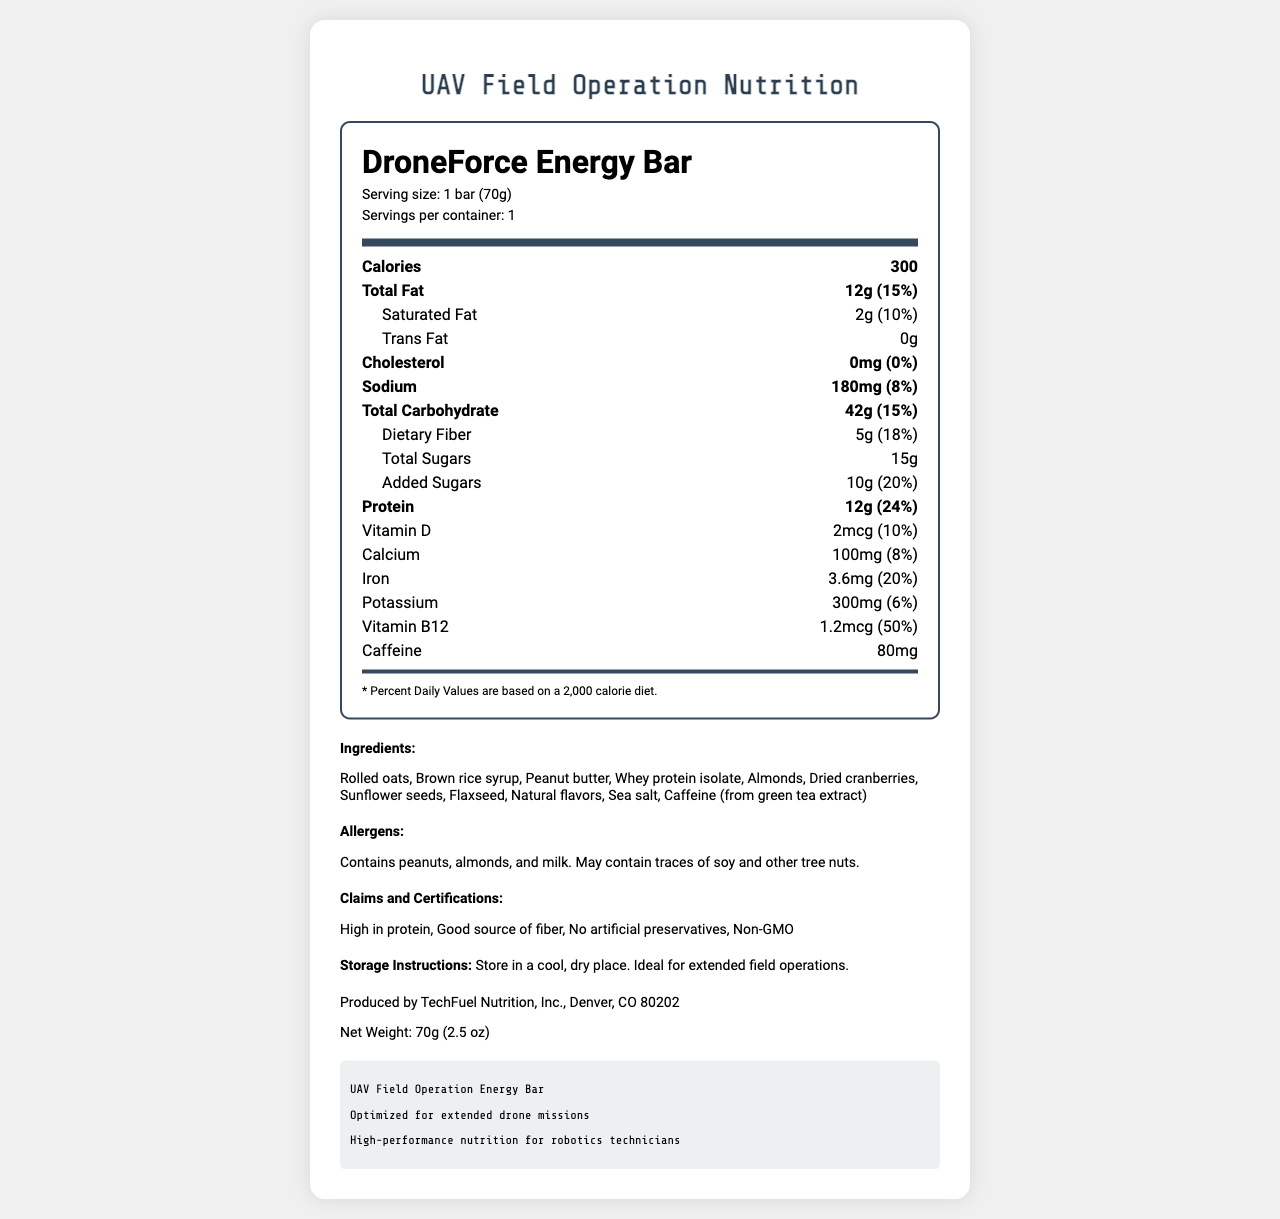what is the serving size of the DroneForce Energy Bar? The serving size is listed under the product name and is indicated as "1 bar (70g)".
Answer: 1 bar (70g) How many calories are in one serving of the DroneForce Energy Bar? The calories per serving are mentioned in bold text under the main nutrients section.
Answer: 300 How much protein does the DroneForce Energy Bar contain? The amount of protein is listed under the main nutrients section with a value of 12g.
Answer: 12g Which ingredient in the DroneForce Energy Bar contains caffeine? The ingredients list mentions "Caffeine (from green tea extract)".
Answer: Caffeine (from green tea extract) What percentage of the daily value is the dietary fiber in the DroneForce Energy Bar? The percentage daily value for dietary fiber is listed next to its amount and is shown as 18%.
Answer: 18% What is the total fat content of the DroneForce Energy Bar? The total fat content is listed under the main nutrients section and is shown as 12g.
Answer: 12g What are two of the claims and certifications associated with the DroneForce Energy Bar? A. Low in calories B. High in protein C. Vegan D. No artificial preservatives The claims and certifications listed are "High in protein," "Good source of fiber," "No artificial preservatives," and "Non-GMO."
Answer: B and D What is the amount of added sugars in the DroneForce Energy Bar? A. 5g B. 10g C. 15g D. 20g The amount of added sugars is listed as 10g in the nutrition facts.
Answer: B Is the DroneForce Energy Bar suitable for someone with a peanut allergy? The allergens section mentions that the product contains peanuts, among other allergens.
Answer: No Describe the general content and purpose of the DroneForce Energy Bar Nutrition Facts label. The label provides comprehensive information about the nutritional content of the DroneForce Energy Bar, including macronutrients like fats, carbohydrates, and proteins, as well as micronutrients such as vitamins and minerals. It also lists ingredients, allergen information, and storage instructions to help users understand what they are consuming and ensure its proper storage.
Answer: The document is a nutritional information label for the DroneForce Energy Bar, detailing its serving size, calories, macronutrient and micronutrient content, ingredients, allergens, claims, certifications, and manufacturer information. The label is designed to inform users, especially those in UAV field operations, about the product's nutritional benefits designed to support extended drone missions. What is the source of sodium in the DroneForce Energy Bar? The label provides the amount and daily value percentage of sodium but does not specify the ingredient source of the sodium.
Answer: Not enough information How many grams of fiber are in one serving? The amount of dietary fiber per serving is listed under the total carbohydrate section and is shown as 5g.
Answer: 5g 